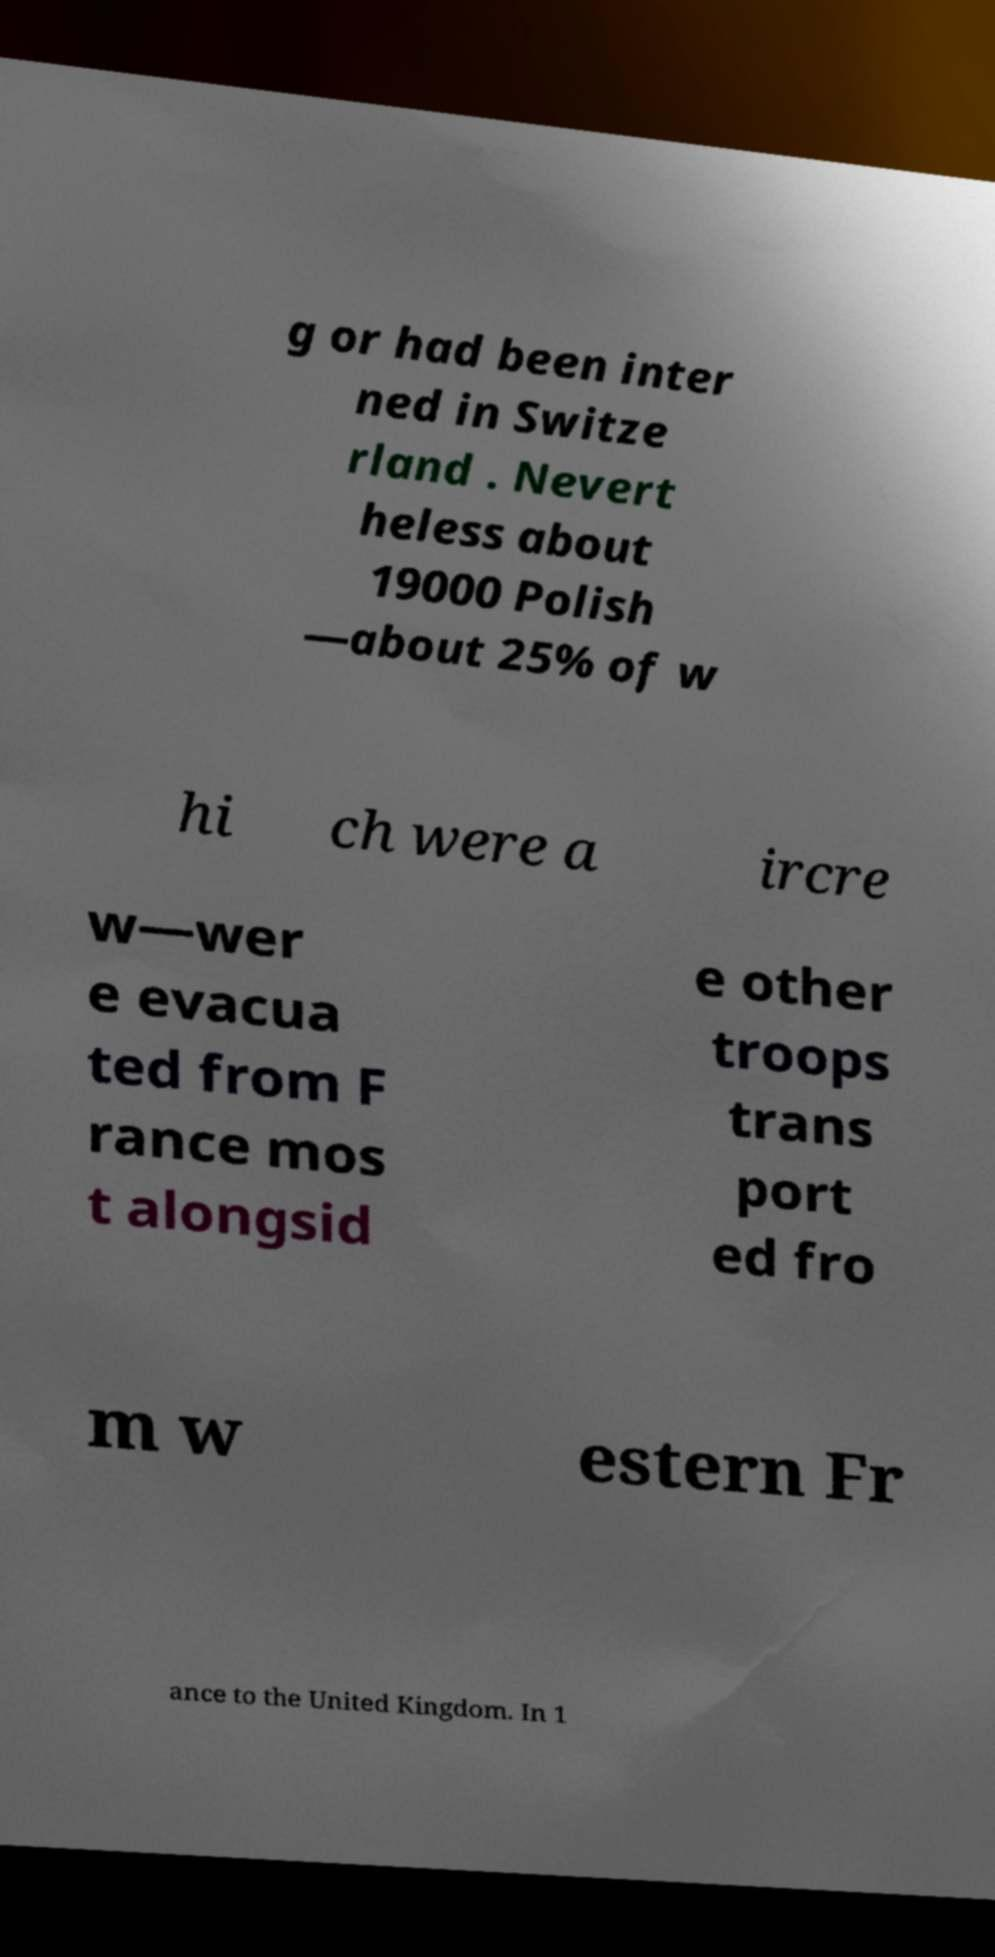Please identify and transcribe the text found in this image. g or had been inter ned in Switze rland . Nevert heless about 19000 Polish —about 25% of w hi ch were a ircre w—wer e evacua ted from F rance mos t alongsid e other troops trans port ed fro m w estern Fr ance to the United Kingdom. In 1 